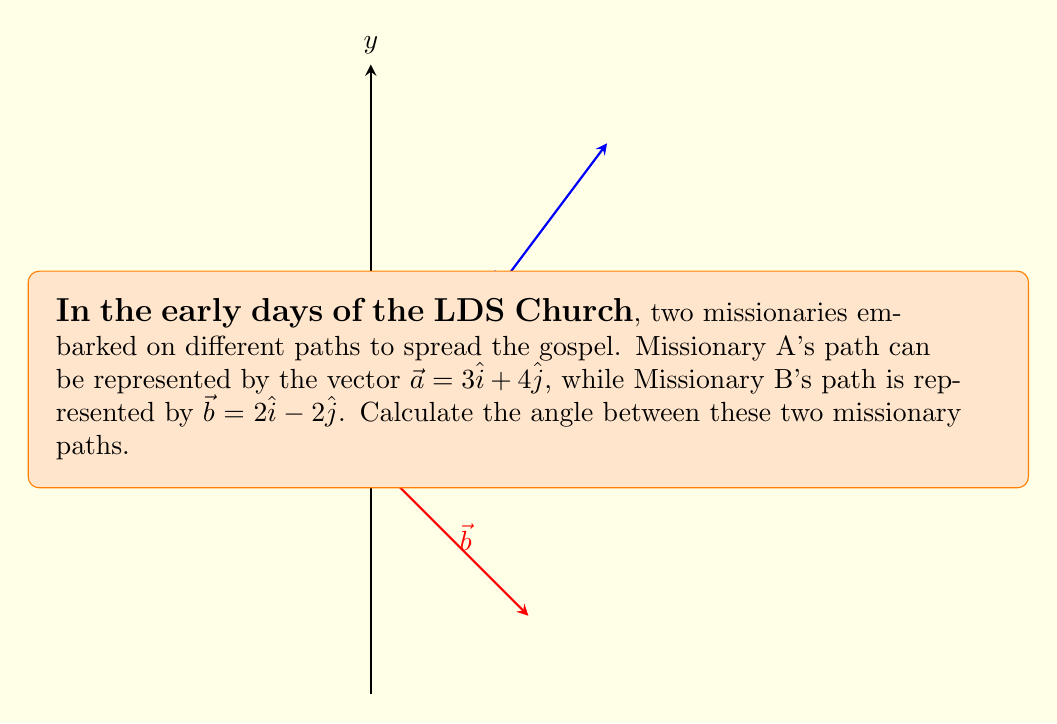Can you solve this math problem? To find the angle between two vectors, we can use the dot product formula:

$$\cos \theta = \frac{\vec{a} \cdot \vec{b}}{|\vec{a}||\vec{b}|}$$

Let's solve this step-by-step:

1) First, calculate the dot product $\vec{a} \cdot \vec{b}$:
   $$\vec{a} \cdot \vec{b} = (3)(2) + (4)(-2) = 6 - 8 = -2$$

2) Calculate the magnitudes of $\vec{a}$ and $\vec{b}$:
   $$|\vec{a}| = \sqrt{3^2 + 4^2} = \sqrt{9 + 16} = \sqrt{25} = 5$$
   $$|\vec{b}| = \sqrt{2^2 + (-2)^2} = \sqrt{4 + 4} = \sqrt{8} = 2\sqrt{2}$$

3) Now, substitute these values into the formula:
   $$\cos \theta = \frac{-2}{5(2\sqrt{2})} = \frac{-2}{10\sqrt{2}} = -\frac{1}{5\sqrt{2}}$$

4) To find $\theta$, we need to take the inverse cosine (arccos) of both sides:
   $$\theta = \arccos(-\frac{1}{5\sqrt{2}})$$

5) Using a calculator or computer, we can evaluate this:
   $$\theta \approx 2.0344 \text{ radians}$$

6) Convert to degrees:
   $$\theta \approx 2.0344 \times \frac{180}{\pi} \approx 116.57°$$
Answer: $116.57°$ 